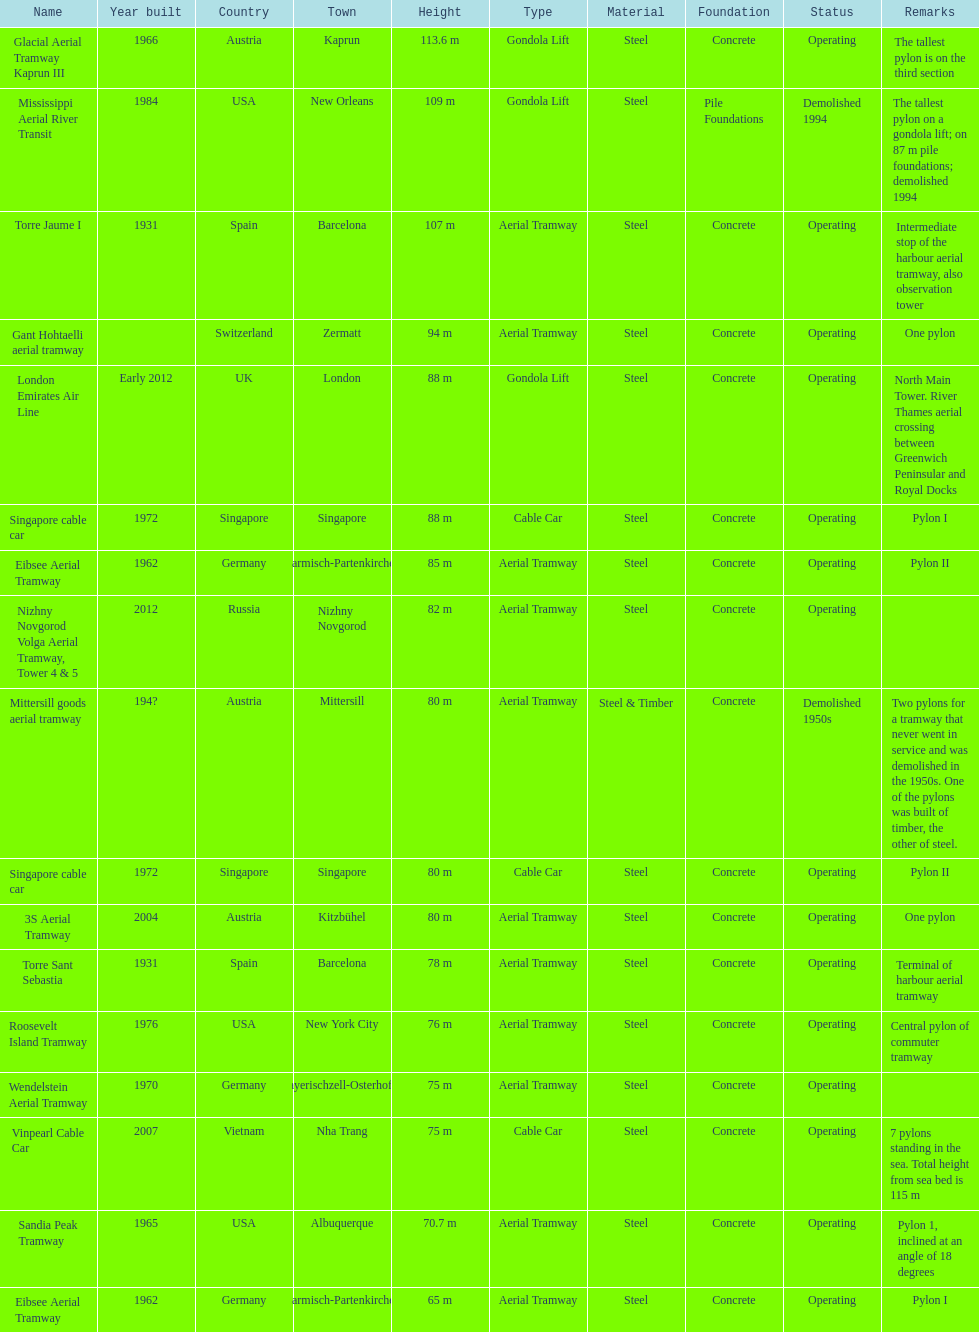What is the pylon with the least height listed here? Eibsee Aerial Tramway. 